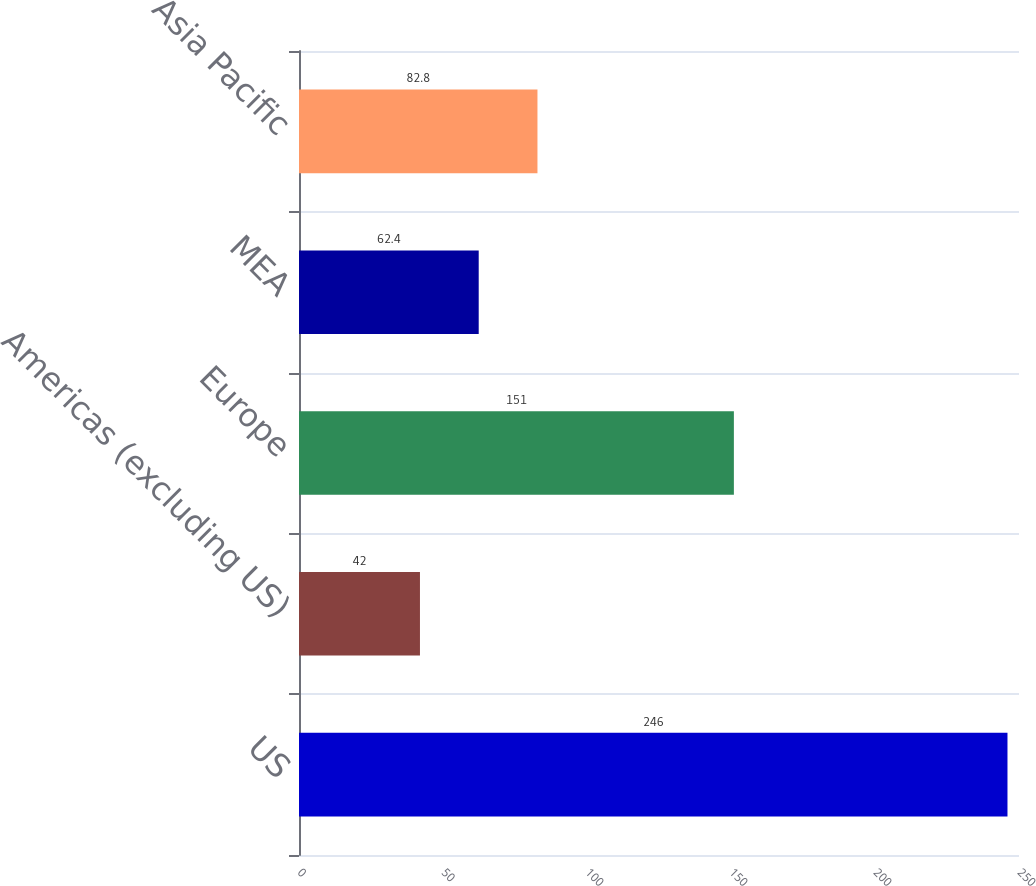Convert chart to OTSL. <chart><loc_0><loc_0><loc_500><loc_500><bar_chart><fcel>US<fcel>Americas (excluding US)<fcel>Europe<fcel>MEA<fcel>Asia Pacific<nl><fcel>246<fcel>42<fcel>151<fcel>62.4<fcel>82.8<nl></chart> 